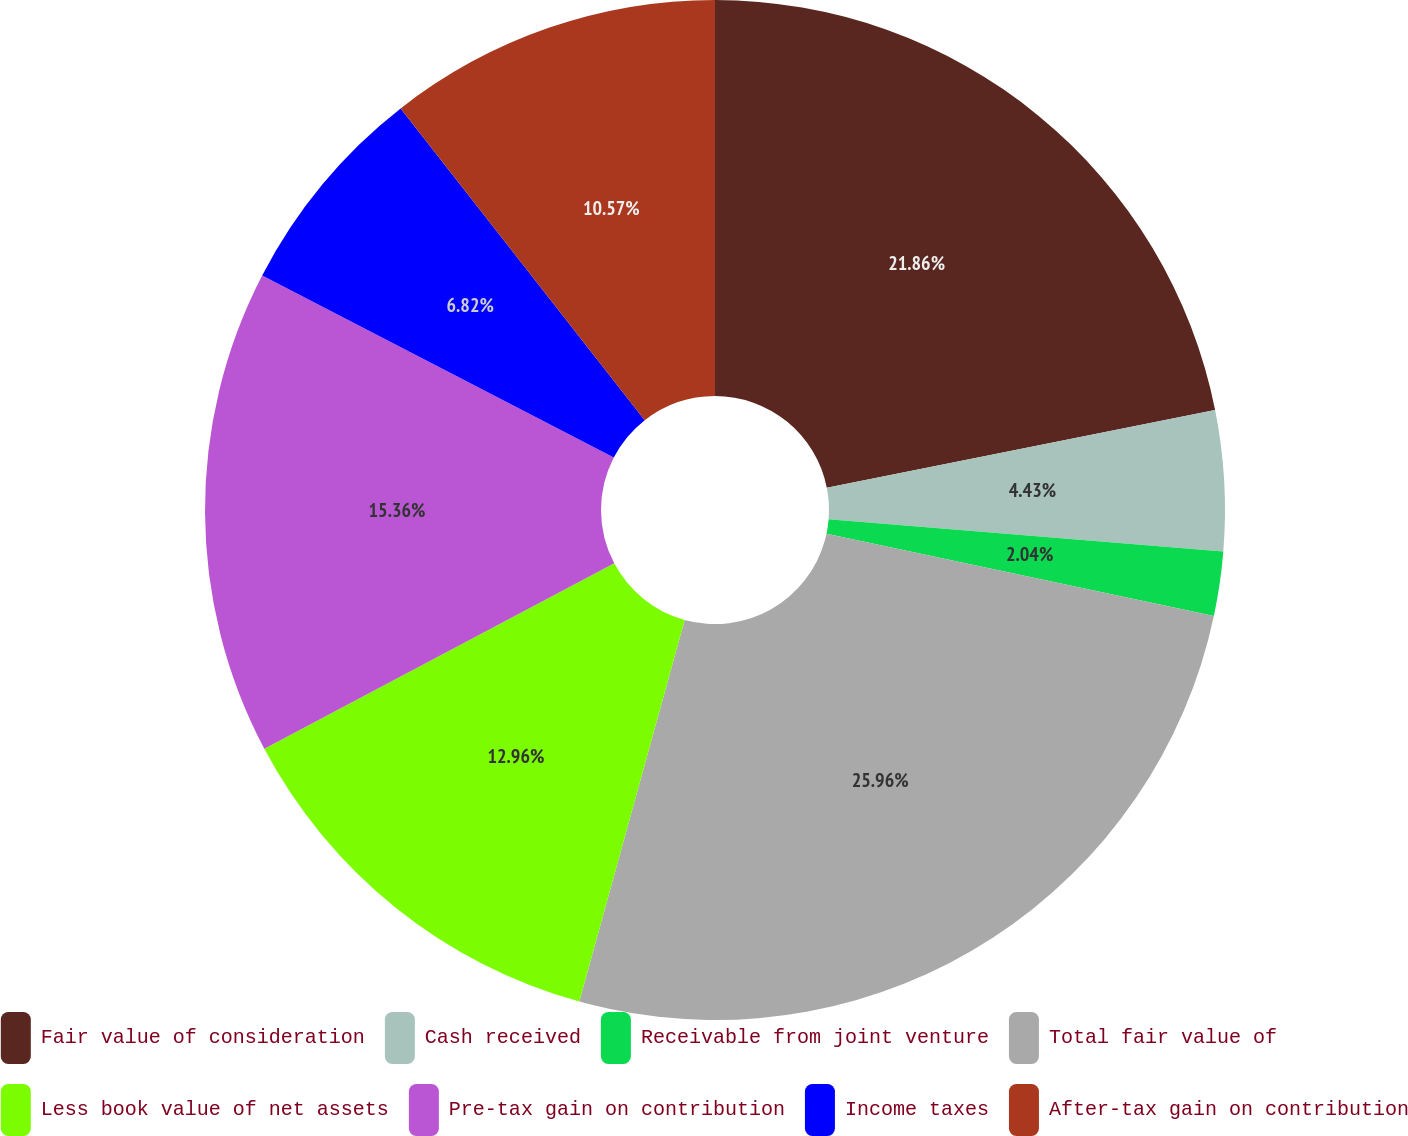<chart> <loc_0><loc_0><loc_500><loc_500><pie_chart><fcel>Fair value of consideration<fcel>Cash received<fcel>Receivable from joint venture<fcel>Total fair value of<fcel>Less book value of net assets<fcel>Pre-tax gain on contribution<fcel>Income taxes<fcel>After-tax gain on contribution<nl><fcel>21.86%<fcel>4.43%<fcel>2.04%<fcel>25.95%<fcel>12.96%<fcel>15.36%<fcel>6.82%<fcel>10.57%<nl></chart> 